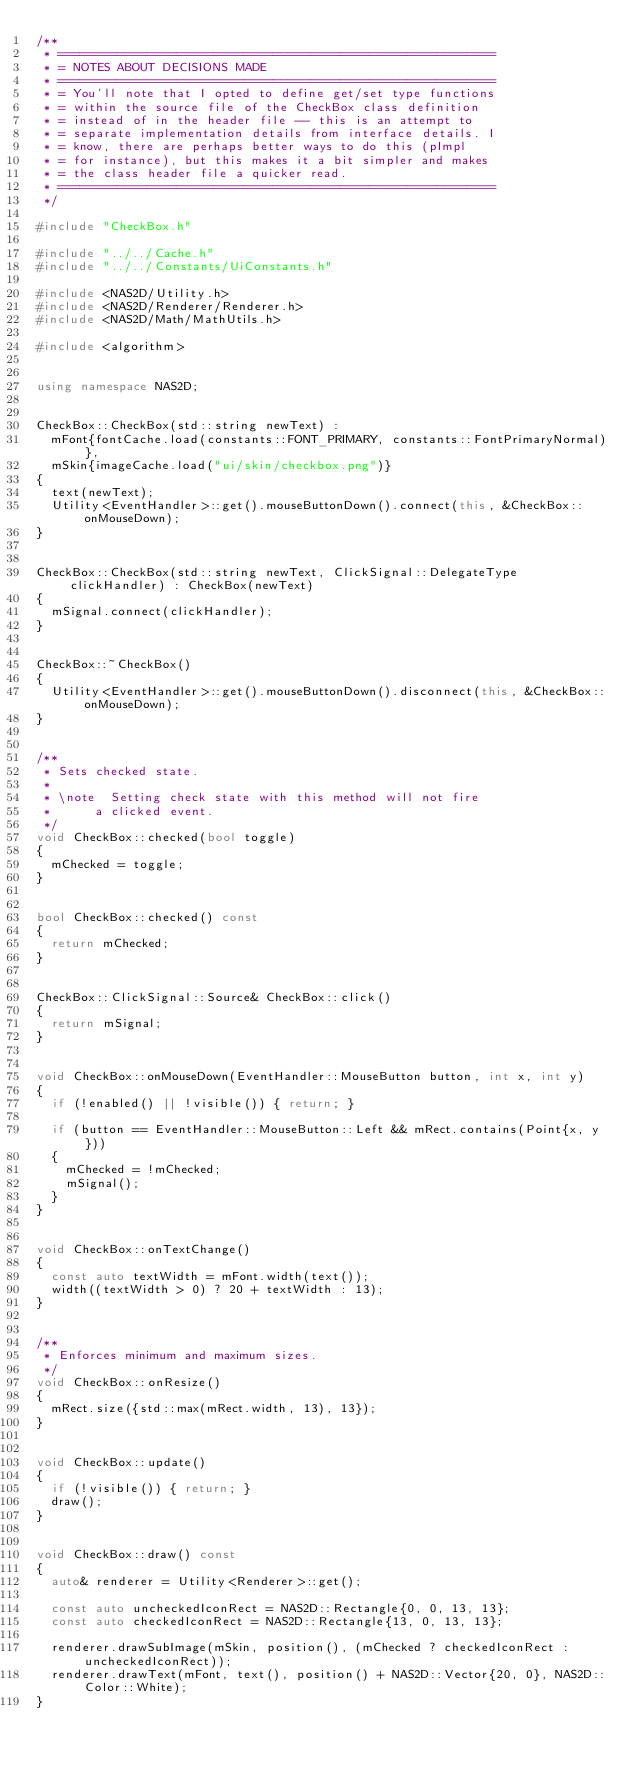Convert code to text. <code><loc_0><loc_0><loc_500><loc_500><_C++_>/**
 * ===========================================================
 * = NOTES ABOUT DECISIONS MADE
 * ===========================================================
 * = You'll note that I opted to define get/set type functions
 * = within the source file of the CheckBox class definition
 * = instead of in the header file -- this is an attempt to
 * = separate implementation details from interface details. I
 * = know, there are perhaps better ways to do this (pImpl
 * = for instance), but this makes it a bit simpler and makes
 * = the class header file a quicker read.
 * ===========================================================
 */

#include "CheckBox.h"

#include "../../Cache.h"
#include "../../Constants/UiConstants.h"

#include <NAS2D/Utility.h>
#include <NAS2D/Renderer/Renderer.h>
#include <NAS2D/Math/MathUtils.h>

#include <algorithm>


using namespace NAS2D;


CheckBox::CheckBox(std::string newText) :
	mFont{fontCache.load(constants::FONT_PRIMARY, constants::FontPrimaryNormal)},
	mSkin{imageCache.load("ui/skin/checkbox.png")}
{
	text(newText);
	Utility<EventHandler>::get().mouseButtonDown().connect(this, &CheckBox::onMouseDown);
}


CheckBox::CheckBox(std::string newText, ClickSignal::DelegateType clickHandler) : CheckBox(newText)
{
	mSignal.connect(clickHandler);
}


CheckBox::~CheckBox()
{
	Utility<EventHandler>::get().mouseButtonDown().disconnect(this, &CheckBox::onMouseDown);
}


/**
 * Sets checked state.
 * 
 * \note	Setting check state with this method will not fire
 *			a clicked event.
 */
void CheckBox::checked(bool toggle)
{
	mChecked = toggle;
}


bool CheckBox::checked() const
{
	return mChecked;
}


CheckBox::ClickSignal::Source& CheckBox::click()
{
	return mSignal;
}


void CheckBox::onMouseDown(EventHandler::MouseButton button, int x, int y)
{
	if (!enabled() || !visible()) { return; }

	if (button == EventHandler::MouseButton::Left && mRect.contains(Point{x, y}))
	{
		mChecked = !mChecked;
		mSignal();
	}
}


void CheckBox::onTextChange()
{
	const auto textWidth = mFont.width(text());
	width((textWidth > 0) ? 20 + textWidth : 13);
}


/**
 * Enforces minimum and maximum sizes.
 */
void CheckBox::onResize()
{
	mRect.size({std::max(mRect.width, 13), 13});
}


void CheckBox::update()
{
	if (!visible()) { return; }
	draw();
}


void CheckBox::draw() const
{
	auto& renderer = Utility<Renderer>::get();

	const auto uncheckedIconRect = NAS2D::Rectangle{0, 0, 13, 13};
	const auto checkedIconRect = NAS2D::Rectangle{13, 0, 13, 13};

	renderer.drawSubImage(mSkin, position(), (mChecked ? checkedIconRect : uncheckedIconRect));
	renderer.drawText(mFont, text(), position() + NAS2D::Vector{20, 0}, NAS2D::Color::White);
}
</code> 